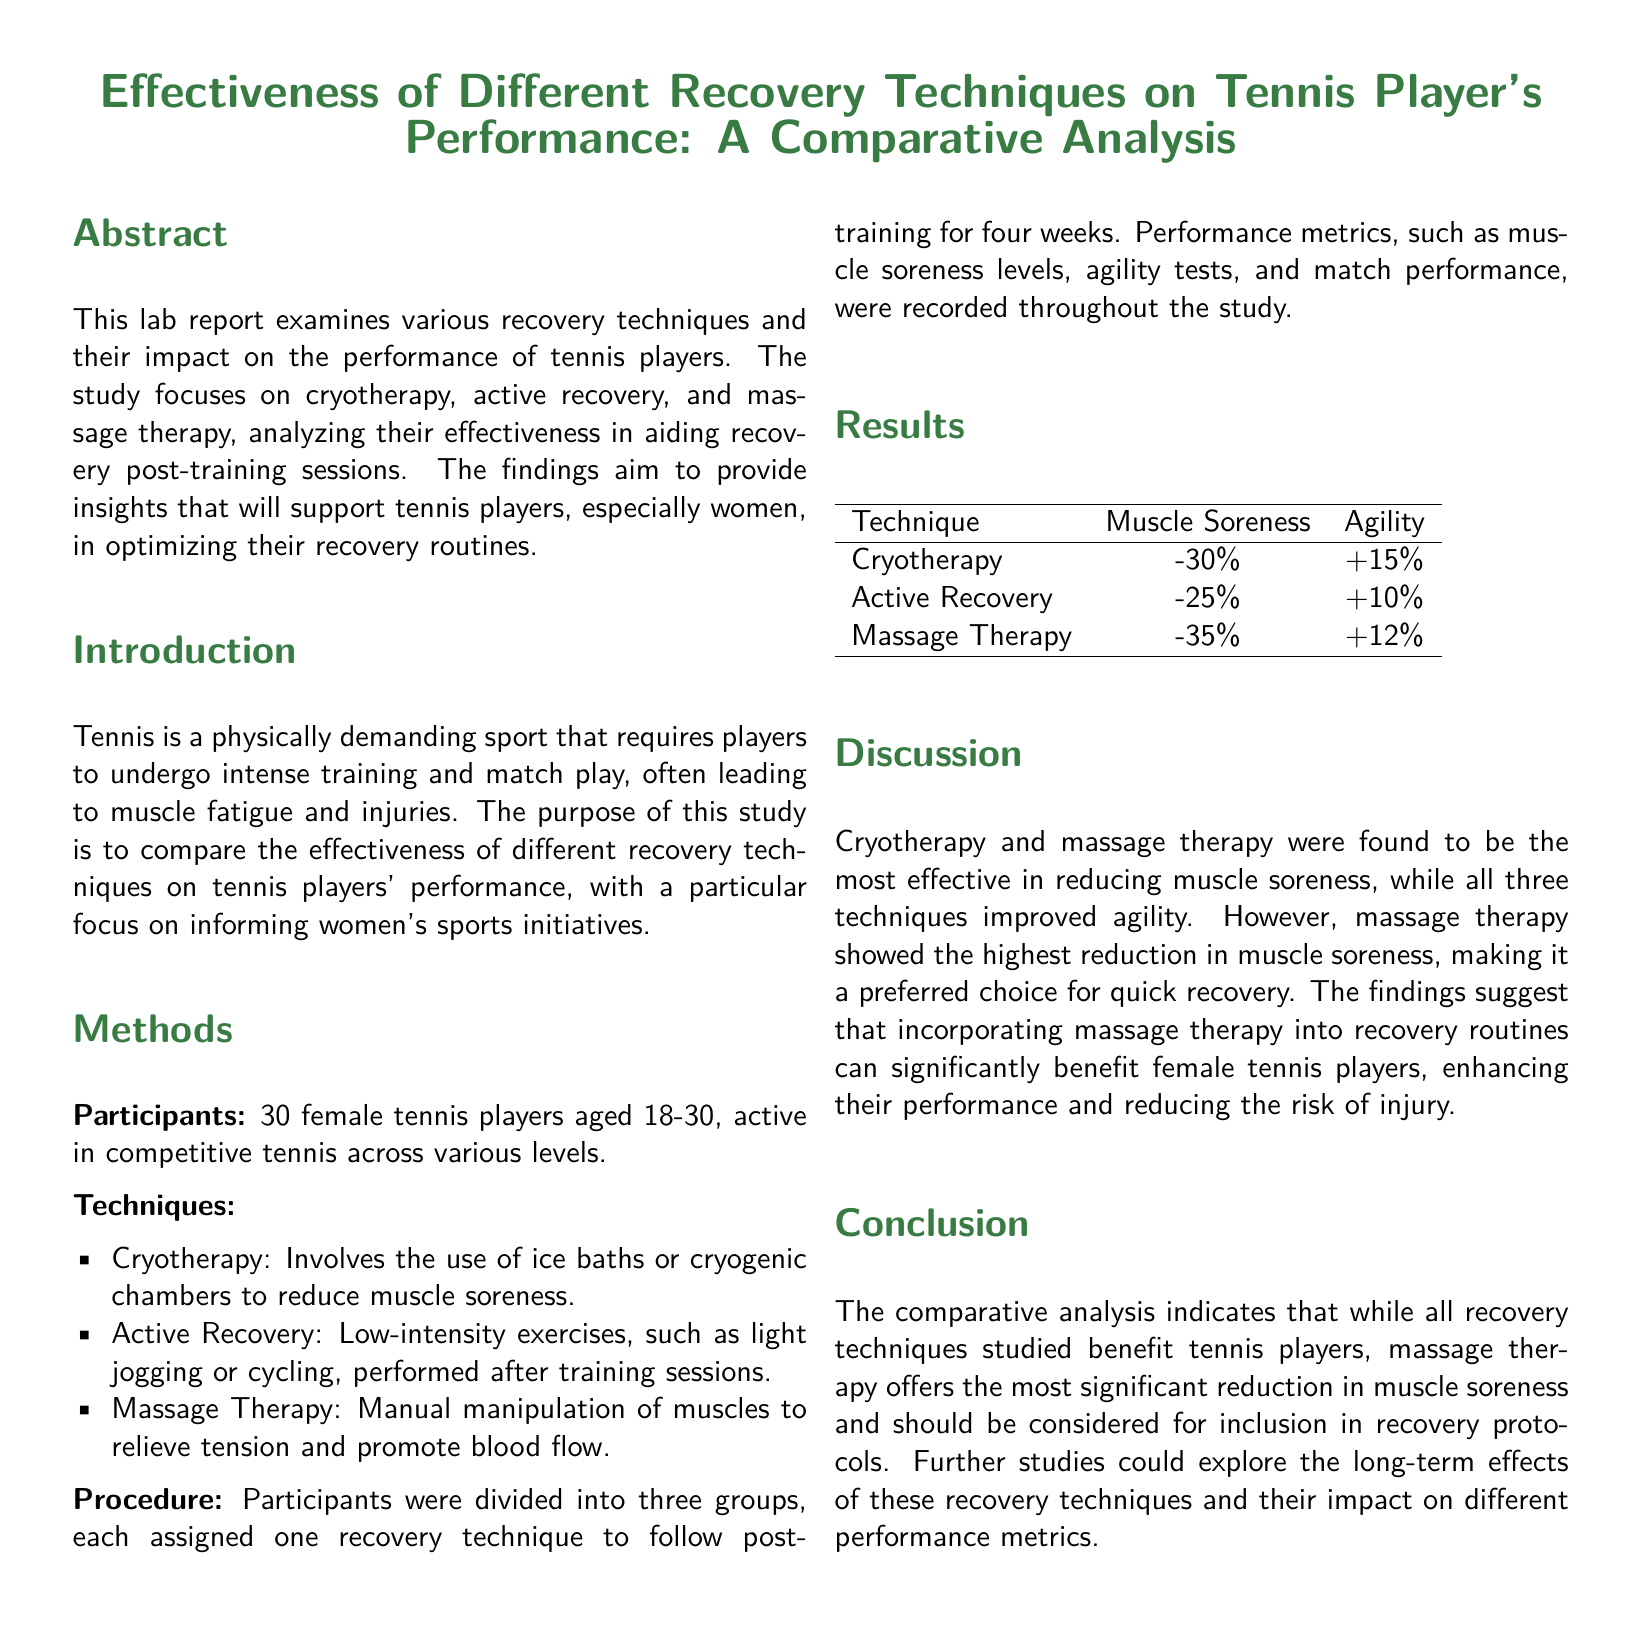what are the three recovery techniques studied? The document lists the recovery techniques as cryotherapy, active recovery, and massage therapy.
Answer: cryotherapy, active recovery, massage therapy how many female tennis players participated in the study? The participant section states that there were 30 female tennis players involved in the study.
Answer: 30 what was the percentage reduction in muscle soreness for massage therapy? The results table indicates a -35% reduction in muscle soreness for massage therapy.
Answer: -35% which recovery technique had the highest increase in agility? The document does not indicate a specific technique with the highest increase, but it states agility improved across all techniques.
Answer: massage therapy what specific age range did the participants belong to? The introduction specifies that the participants were aged 18-30 years old.
Answer: 18-30 which recovery technique was suggested for quick recovery? In the discussion section, it is mentioned that massage therapy is the preferred choice for quick recovery.
Answer: massage therapy what was the main focus of the study? The study aimed to compare the effectiveness of different recovery techniques on tennis players' performance, focusing on women's sports.
Answer: effectiveness of different recovery techniques which recovery technique showed the lowest reduction in muscle soreness? In the results table, active recovery showed a -25% reduction, which is the lowest among the techniques studied.
Answer: active recovery what aspect of tennis players' performance was primarily measured? The study measured muscle soreness levels, agility tests, and match performance as key aspects of performance.
Answer: muscle soreness, agility, match performance 